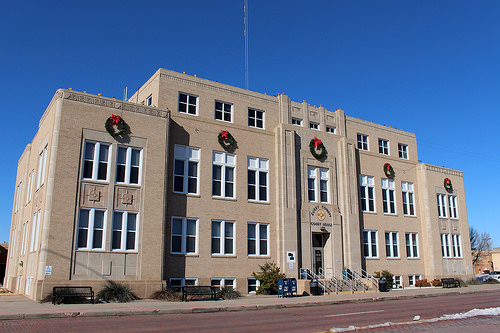<image>
Is there a building in the road? No. The building is not contained within the road. These objects have a different spatial relationship. 